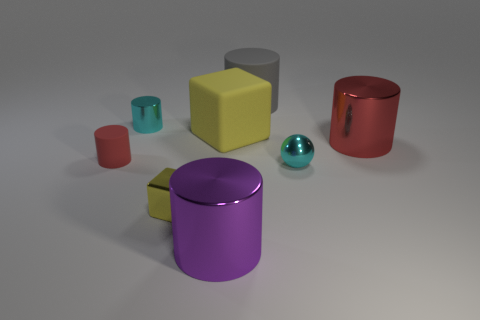Subtract 2 cylinders. How many cylinders are left? 3 Subtract all cyan cylinders. How many cylinders are left? 4 Subtract all big rubber cylinders. How many cylinders are left? 4 Subtract all yellow cylinders. Subtract all blue balls. How many cylinders are left? 5 Add 2 small yellow metal things. How many objects exist? 10 Subtract all spheres. How many objects are left? 7 Subtract all green cylinders. Subtract all purple shiny things. How many objects are left? 7 Add 8 red matte cylinders. How many red matte cylinders are left? 9 Add 8 yellow matte blocks. How many yellow matte blocks exist? 9 Subtract 0 brown blocks. How many objects are left? 8 